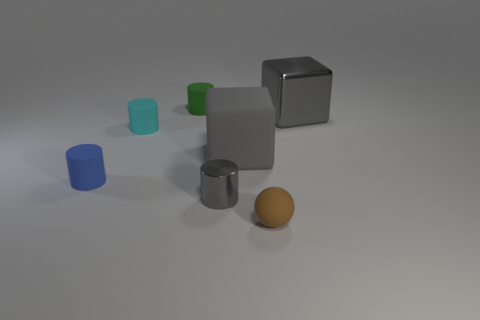What number of things are either big gray things to the left of the gray metallic cube or small things that are to the left of the small green cylinder? There are two large gray objects to the left of the gray metallic cube and one small object to the left of the small green cylinder, making a total of 3 items fitting the description. 